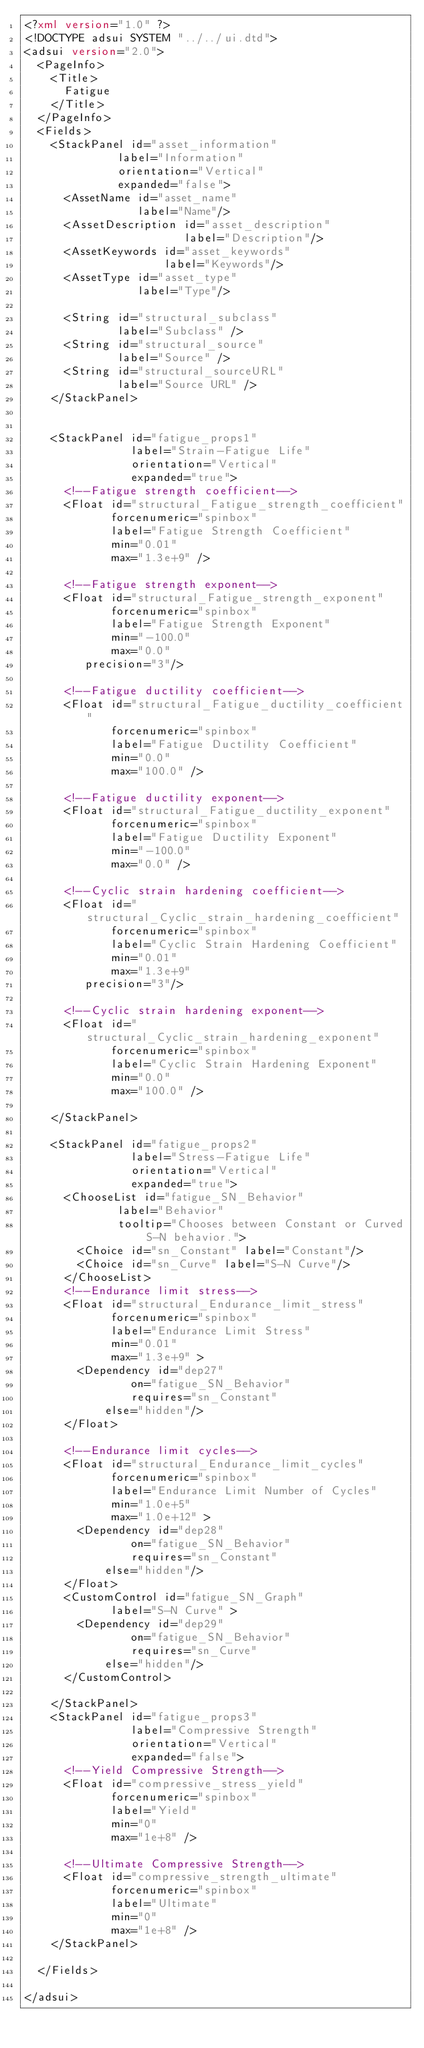Convert code to text. <code><loc_0><loc_0><loc_500><loc_500><_XML_><?xml version="1.0" ?>
<!DOCTYPE adsui SYSTEM "../../ui.dtd">
<adsui version="2.0">
  <PageInfo>
    <Title>
      Fatigue
    </Title>
  </PageInfo>
  <Fields>
    <StackPanel id="asset_information"
              label="Information"
              orientation="Vertical"
              expanded="false">
      <AssetName id="asset_name"
                 label="Name"/>
      <AssetDescription id="asset_description"
                        label="Description"/>
      <AssetKeywords id="asset_keywords"
                     label="Keywords"/>
      <AssetType id="asset_type"
                 label="Type"/>

      <String id="structural_subclass"
              label="Subclass" />
      <String id="structural_source"
              label="Source" />
      <String id="structural_sourceURL"
              label="Source URL" />
    </StackPanel>

    
    <StackPanel id="fatigue_props1"
                label="Strain-Fatigue Life"
                orientation="Vertical"
                expanded="true">
      <!--Fatigue strength coefficient-->
      <Float id="structural_Fatigue_strength_coefficient"
             forcenumeric="spinbox"
             label="Fatigue Strength Coefficient"
             min="0.01"
             max="1.3e+9" />
     
      <!--Fatigue strength exponent-->
      <Float id="structural_Fatigue_strength_exponent"
             forcenumeric="spinbox"
             label="Fatigue Strength Exponent"
             min="-100.0"
             max="0.0" 
	     precision="3"/>

      <!--Fatigue ductility coefficient-->
      <Float id="structural_Fatigue_ductility_coefficient"
             forcenumeric="spinbox"
             label="Fatigue Ductility Coefficient"
             min="0.0"
             max="100.0" />
      
      <!--Fatigue ductility exponent-->
      <Float id="structural_Fatigue_ductility_exponent"
             forcenumeric="spinbox"
             label="Fatigue Ductility Exponent"
             min="-100.0"
             max="0.0" />

      <!--Cyclic strain hardening coefficient-->
      <Float id="structural_Cyclic_strain_hardening_coefficient"
             forcenumeric="spinbox"
             label="Cyclic Strain Hardening Coefficient"
             min="0.01"
             max="1.3e+9" 
	     precision="3"/>

      <!--Cyclic strain hardening exponent-->
      <Float id="structural_Cyclic_strain_hardening_exponent"
             forcenumeric="spinbox"
             label="Cyclic Strain Hardening Exponent"
             min="0.0"
             max="100.0" />
      
    </StackPanel>

    <StackPanel id="fatigue_props2"
                label="Stress-Fatigue Life"
                orientation="Vertical"
                expanded="true">
	  <ChooseList id="fatigue_SN_Behavior"
			  label="Behavior"
			  tooltip="Chooses between Constant or Curved S-N behavior.">
	    <Choice id="sn_Constant" label="Constant"/>
	    <Choice id="sn_Curve" label="S-N Curve"/>
	  </ChooseList>		
      <!--Endurance limit stress-->
      <Float id="structural_Endurance_limit_stress"
             forcenumeric="spinbox"
             label="Endurance Limit Stress"
             min="0.01"
             max="1.3e+9" >
		<Dependency id="dep27"
	            on="fatigue_SN_Behavior"
	            requires="sn_Constant"
		    else="hidden"/>
	  </Float>

      <!--Endurance limit cycles-->
      <Float id="structural_Endurance_limit_cycles"
             forcenumeric="spinbox"
             label="Endurance Limit Number of Cycles"
             min="1.0e+5"
             max="1.0e+12" >
		<Dependency id="dep28"
	            on="fatigue_SN_Behavior"
	            requires="sn_Constant"
		    else="hidden"/>
	  </Float>
	  <CustomControl id="fatigue_SN_Graph" 
			 label="S-N Curve" >
		<Dependency id="dep29"
	            on="fatigue_SN_Behavior"
	            requires="sn_Curve"
		    else="hidden"/>
	  </CustomControl>

    </StackPanel>
	<StackPanel id="fatigue_props3"
                label="Compressive Strength"
                orientation="Vertical"
                expanded="false">
      <!--Yield Compressive Strength-->
      <Float id="compressive_stress_yield"
             forcenumeric="spinbox"
             label="Yield"
             min="0"
             max="1e+8" />
     
      <!--Ultimate Compressive Strength-->
      <Float id="compressive_strength_ultimate"
             forcenumeric="spinbox"
             label="Ultimate"
             min="0"
             max="1e+8" />     
    </StackPanel>

  </Fields>

</adsui>
</code> 